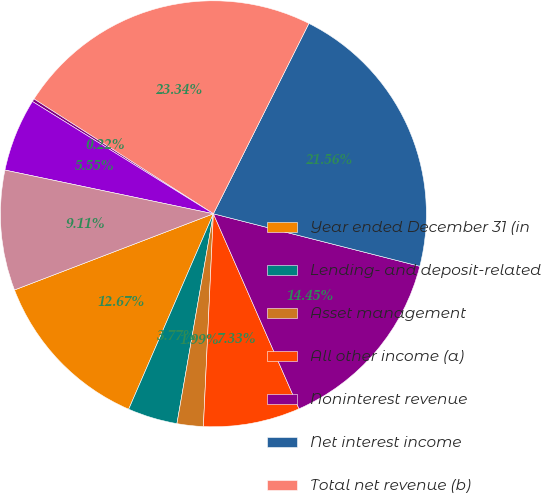<chart> <loc_0><loc_0><loc_500><loc_500><pie_chart><fcel>Year ended December 31 (in<fcel>Lending- and deposit-related<fcel>Asset management<fcel>All other income (a)<fcel>Noninterest revenue<fcel>Net interest income<fcel>Total net revenue (b)<fcel>Provision for credit losses<fcel>Compensation expense<fcel>Noncompensation expense<nl><fcel>12.67%<fcel>3.77%<fcel>1.99%<fcel>7.33%<fcel>14.45%<fcel>21.56%<fcel>23.34%<fcel>0.22%<fcel>5.55%<fcel>9.11%<nl></chart> 